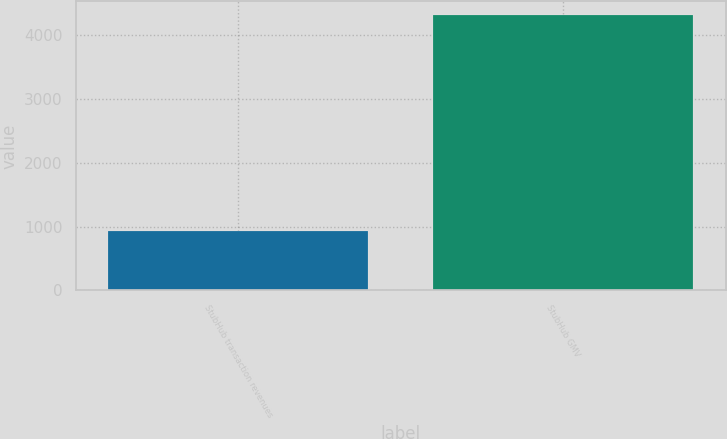<chart> <loc_0><loc_0><loc_500><loc_500><bar_chart><fcel>StubHub transaction revenues<fcel>StubHub GMV<nl><fcel>937<fcel>4310<nl></chart> 